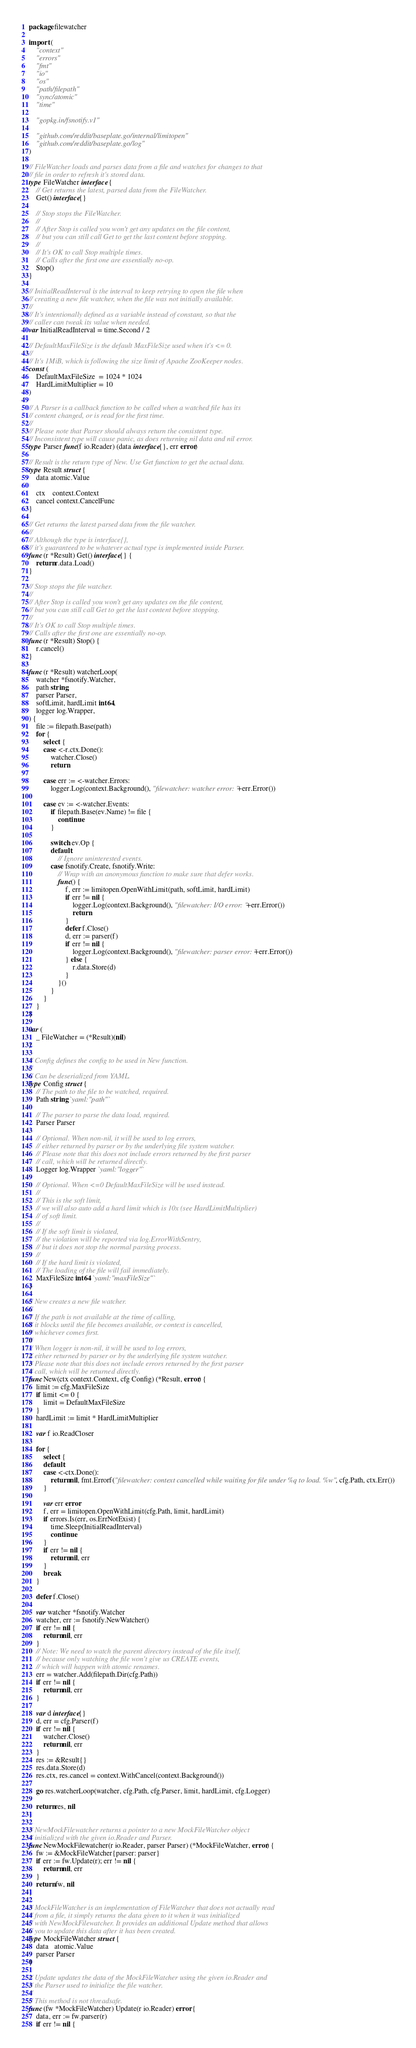<code> <loc_0><loc_0><loc_500><loc_500><_Go_>package filewatcher

import (
	"context"
	"errors"
	"fmt"
	"io"
	"os"
	"path/filepath"
	"sync/atomic"
	"time"

	"gopkg.in/fsnotify.v1"

	"github.com/reddit/baseplate.go/internal/limitopen"
	"github.com/reddit/baseplate.go/log"
)

// FileWatcher loads and parses data from a file and watches for changes to that
// file in order to refresh it's stored data.
type FileWatcher interface {
	// Get returns the latest, parsed data from the FileWatcher.
	Get() interface{}

	// Stop stops the FileWatcher.
	//
	// After Stop is called you won't get any updates on the file content,
	// but you can still call Get to get the last content before stopping.
	//
	// It's OK to call Stop multiple times.
	// Calls after the first one are essentially no-op.
	Stop()
}

// InitialReadInterval is the interval to keep retrying to open the file when
// creating a new file watcher, when the file was not initially available.
//
// It's intentionally defined as a variable instead of constant, so that the
// caller can tweak its value when needed.
var InitialReadInterval = time.Second / 2

// DefaultMaxFileSize is the default MaxFileSize used when it's <= 0.
//
// It's 1MiB, which is following the size limit of Apache ZooKeeper nodes.
const (
	DefaultMaxFileSize  = 1024 * 1024
	HardLimitMultiplier = 10
)

// A Parser is a callback function to be called when a watched file has its
// content changed, or is read for the first time.
//
// Please note that Parser should always return the consistent type.
// Inconsistent type will cause panic, as does returning nil data and nil error.
type Parser func(f io.Reader) (data interface{}, err error)

// Result is the return type of New. Use Get function to get the actual data.
type Result struct {
	data atomic.Value

	ctx    context.Context
	cancel context.CancelFunc
}

// Get returns the latest parsed data from the file watcher.
//
// Although the type is interface{},
// it's guaranteed to be whatever actual type is implemented inside Parser.
func (r *Result) Get() interface{} {
	return r.data.Load()
}

// Stop stops the file watcher.
//
// After Stop is called you won't get any updates on the file content,
// but you can still call Get to get the last content before stopping.
//
// It's OK to call Stop multiple times.
// Calls after the first one are essentially no-op.
func (r *Result) Stop() {
	r.cancel()
}

func (r *Result) watcherLoop(
	watcher *fsnotify.Watcher,
	path string,
	parser Parser,
	softLimit, hardLimit int64,
	logger log.Wrapper,
) {
	file := filepath.Base(path)
	for {
		select {
		case <-r.ctx.Done():
			watcher.Close()
			return

		case err := <-watcher.Errors:
			logger.Log(context.Background(), "filewatcher: watcher error: "+err.Error())

		case ev := <-watcher.Events:
			if filepath.Base(ev.Name) != file {
				continue
			}

			switch ev.Op {
			default:
				// Ignore uninterested events.
			case fsnotify.Create, fsnotify.Write:
				// Wrap with an anonymous function to make sure that defer works.
				func() {
					f, err := limitopen.OpenWithLimit(path, softLimit, hardLimit)
					if err != nil {
						logger.Log(context.Background(), "filewatcher: I/O error: "+err.Error())
						return
					}
					defer f.Close()
					d, err := parser(f)
					if err != nil {
						logger.Log(context.Background(), "filewatcher: parser error: "+err.Error())
					} else {
						r.data.Store(d)
					}
				}()
			}
		}
	}
}

var (
	_ FileWatcher = (*Result)(nil)
)

// Config defines the config to be used in New function.
//
// Can be deserialized from YAML.
type Config struct {
	// The path to the file to be watched, required.
	Path string `yaml:"path"`

	// The parser to parse the data load, required.
	Parser Parser

	// Optional. When non-nil, it will be used to log errors,
	// either returned by parser or by the underlying file system watcher.
	// Please note that this does not include errors returned by the first parser
	// call, which will be returned directly.
	Logger log.Wrapper `yaml:"logger"`

	// Optional. When <=0 DefaultMaxFileSize will be used instead.
	//
	// This is the soft limit,
	// we will also auto add a hard limit which is 10x (see HardLimitMultiplier)
	// of soft limit.
	//
	// If the soft limit is violated,
	// the violation will be reported via log.ErrorWithSentry,
	// but it does not stop the normal parsing process.
	//
	// If the hard limit is violated,
	// The loading of the file will fail immediately.
	MaxFileSize int64 `yaml:"maxFileSize"`
}

// New creates a new file watcher.
//
// If the path is not available at the time of calling,
// it blocks until the file becomes available, or context is cancelled,
// whichever comes first.
//
// When logger is non-nil, it will be used to log errors,
// either returned by parser or by the underlying file system watcher.
// Please note that this does not include errors returned by the first parser
// call, which will be returned directly.
func New(ctx context.Context, cfg Config) (*Result, error) {
	limit := cfg.MaxFileSize
	if limit <= 0 {
		limit = DefaultMaxFileSize
	}
	hardLimit := limit * HardLimitMultiplier

	var f io.ReadCloser

	for {
		select {
		default:
		case <-ctx.Done():
			return nil, fmt.Errorf("filewatcher: context cancelled while waiting for file under %q to load. %w", cfg.Path, ctx.Err())
		}

		var err error
		f, err = limitopen.OpenWithLimit(cfg.Path, limit, hardLimit)
		if errors.Is(err, os.ErrNotExist) {
			time.Sleep(InitialReadInterval)
			continue
		}
		if err != nil {
			return nil, err
		}
		break
	}

	defer f.Close()

	var watcher *fsnotify.Watcher
	watcher, err := fsnotify.NewWatcher()
	if err != nil {
		return nil, err
	}
	// Note: We need to watch the parent directory instead of the file itself,
	// because only watching the file won't give us CREATE events,
	// which will happen with atomic renames.
	err = watcher.Add(filepath.Dir(cfg.Path))
	if err != nil {
		return nil, err
	}

	var d interface{}
	d, err = cfg.Parser(f)
	if err != nil {
		watcher.Close()
		return nil, err
	}
	res := &Result{}
	res.data.Store(d)
	res.ctx, res.cancel = context.WithCancel(context.Background())

	go res.watcherLoop(watcher, cfg.Path, cfg.Parser, limit, hardLimit, cfg.Logger)

	return res, nil
}

// NewMockFilewatcher returns a pointer to a new MockFileWatcher object
// initialized with the given io.Reader and Parser.
func NewMockFilewatcher(r io.Reader, parser Parser) (*MockFileWatcher, error) {
	fw := &MockFileWatcher{parser: parser}
	if err := fw.Update(r); err != nil {
		return nil, err
	}
	return fw, nil
}

// MockFileWatcher is an implementation of FileWatcher that does not actually read
// from a file, it simply returns the data given to it when it was initialized
// with NewMockFilewatcher. It provides an additional Update method that allows
// you to update this data after it has been created.
type MockFileWatcher struct {
	data   atomic.Value
	parser Parser
}

// Update updates the data of the MockFileWatcher using the given io.Reader and
// the Parser used to initialize the file watcher.
//
// This method is not threadsafe.
func (fw *MockFileWatcher) Update(r io.Reader) error {
	data, err := fw.parser(r)
	if err != nil {</code> 